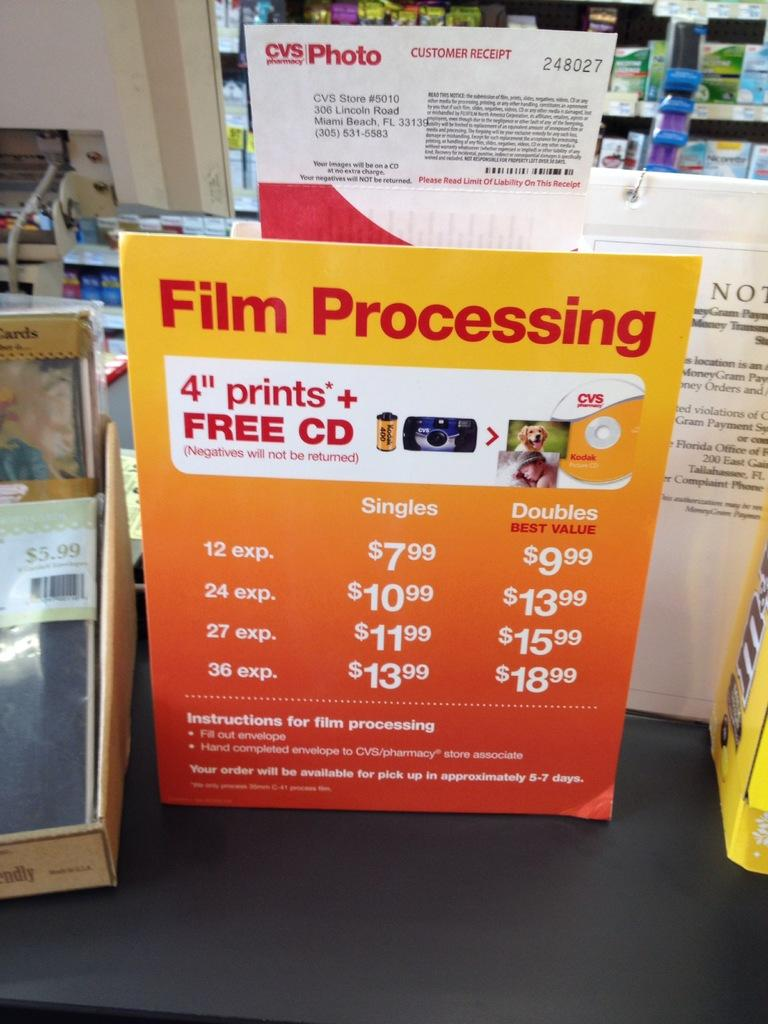<image>
Present a compact description of the photo's key features. CVS offered Photo Film Processing of 4-inch prints and a Free CD at reasonable prices for Single or Double prints. 